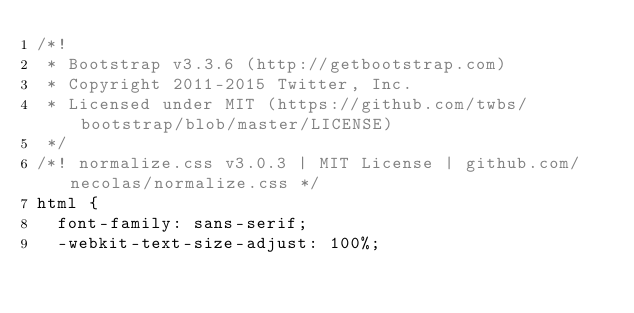<code> <loc_0><loc_0><loc_500><loc_500><_CSS_>/*!
 * Bootstrap v3.3.6 (http://getbootstrap.com)
 * Copyright 2011-2015 Twitter, Inc.
 * Licensed under MIT (https://github.com/twbs/bootstrap/blob/master/LICENSE)
 */
/*! normalize.css v3.0.3 | MIT License | github.com/necolas/normalize.css */
html {
  font-family: sans-serif;
  -webkit-text-size-adjust: 100%;</code> 